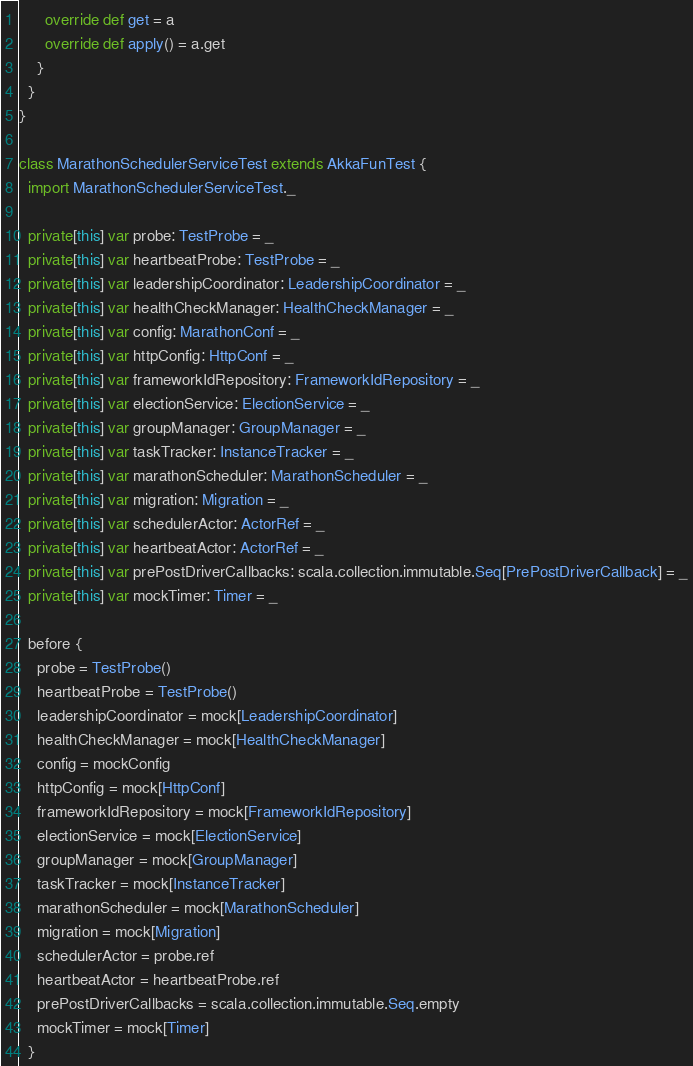Convert code to text. <code><loc_0><loc_0><loc_500><loc_500><_Scala_>      override def get = a
      override def apply() = a.get
    }
  }
}

class MarathonSchedulerServiceTest extends AkkaFunTest {
  import MarathonSchedulerServiceTest._

  private[this] var probe: TestProbe = _
  private[this] var heartbeatProbe: TestProbe = _
  private[this] var leadershipCoordinator: LeadershipCoordinator = _
  private[this] var healthCheckManager: HealthCheckManager = _
  private[this] var config: MarathonConf = _
  private[this] var httpConfig: HttpConf = _
  private[this] var frameworkIdRepository: FrameworkIdRepository = _
  private[this] var electionService: ElectionService = _
  private[this] var groupManager: GroupManager = _
  private[this] var taskTracker: InstanceTracker = _
  private[this] var marathonScheduler: MarathonScheduler = _
  private[this] var migration: Migration = _
  private[this] var schedulerActor: ActorRef = _
  private[this] var heartbeatActor: ActorRef = _
  private[this] var prePostDriverCallbacks: scala.collection.immutable.Seq[PrePostDriverCallback] = _
  private[this] var mockTimer: Timer = _

  before {
    probe = TestProbe()
    heartbeatProbe = TestProbe()
    leadershipCoordinator = mock[LeadershipCoordinator]
    healthCheckManager = mock[HealthCheckManager]
    config = mockConfig
    httpConfig = mock[HttpConf]
    frameworkIdRepository = mock[FrameworkIdRepository]
    electionService = mock[ElectionService]
    groupManager = mock[GroupManager]
    taskTracker = mock[InstanceTracker]
    marathonScheduler = mock[MarathonScheduler]
    migration = mock[Migration]
    schedulerActor = probe.ref
    heartbeatActor = heartbeatProbe.ref
    prePostDriverCallbacks = scala.collection.immutable.Seq.empty
    mockTimer = mock[Timer]
  }
</code> 